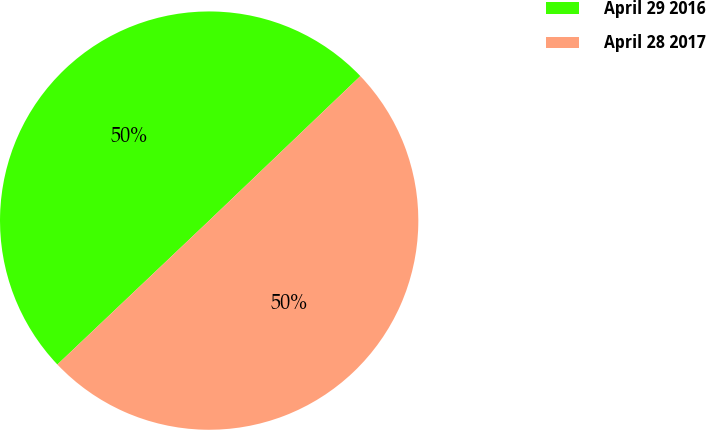Convert chart to OTSL. <chart><loc_0><loc_0><loc_500><loc_500><pie_chart><fcel>April 29 2016<fcel>April 28 2017<nl><fcel>49.94%<fcel>50.06%<nl></chart> 